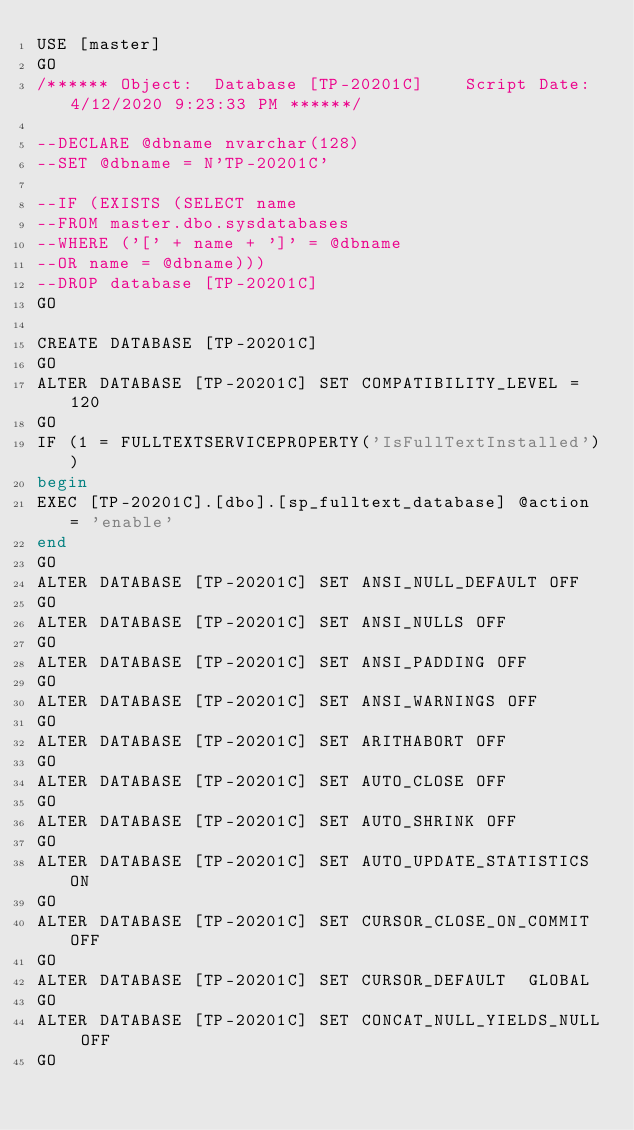Convert code to text. <code><loc_0><loc_0><loc_500><loc_500><_SQL_>USE [master]
GO
/****** Object:  Database [TP-20201C]    Script Date: 4/12/2020 9:23:33 PM ******/

--DECLARE @dbname nvarchar(128)
--SET @dbname = N'TP-20201C'

--IF (EXISTS (SELECT name 
--FROM master.dbo.sysdatabases 
--WHERE ('[' + name + ']' = @dbname 
--OR name = @dbname)))
--DROP database [TP-20201C]
GO

CREATE DATABASE [TP-20201C]
GO
ALTER DATABASE [TP-20201C] SET COMPATIBILITY_LEVEL = 120
GO
IF (1 = FULLTEXTSERVICEPROPERTY('IsFullTextInstalled'))
begin
EXEC [TP-20201C].[dbo].[sp_fulltext_database] @action = 'enable'
end
GO
ALTER DATABASE [TP-20201C] SET ANSI_NULL_DEFAULT OFF 
GO
ALTER DATABASE [TP-20201C] SET ANSI_NULLS OFF 
GO
ALTER DATABASE [TP-20201C] SET ANSI_PADDING OFF 
GO
ALTER DATABASE [TP-20201C] SET ANSI_WARNINGS OFF 
GO
ALTER DATABASE [TP-20201C] SET ARITHABORT OFF 
GO
ALTER DATABASE [TP-20201C] SET AUTO_CLOSE OFF 
GO
ALTER DATABASE [TP-20201C] SET AUTO_SHRINK OFF 
GO
ALTER DATABASE [TP-20201C] SET AUTO_UPDATE_STATISTICS ON 
GO
ALTER DATABASE [TP-20201C] SET CURSOR_CLOSE_ON_COMMIT OFF 
GO
ALTER DATABASE [TP-20201C] SET CURSOR_DEFAULT  GLOBAL 
GO
ALTER DATABASE [TP-20201C] SET CONCAT_NULL_YIELDS_NULL OFF 
GO</code> 